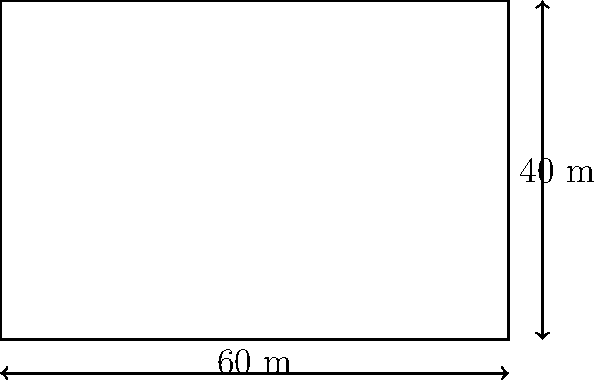Un client vous consulte concernant l'achat d'un terrain rectangulaire pour un projet immobilier. Le terrain mesure 60 mètres de long et 40 mètres de large. Quelle est la superficie totale du terrain en mètres carrés ? Pour calculer la superficie d'un terrain rectangulaire, nous utilisons la formule de l'aire d'un rectangle :

$$ A = l \times L $$

Où :
$A$ = l'aire (superficie)
$l$ = la largeur
$L$ = la longueur

Dans ce cas :
$l = 40$ mètres
$L = 60$ mètres

Appliquons la formule :

$$ A = 40 \times 60 = 2400 $$

Donc, la superficie totale du terrain est de 2400 mètres carrés.

Il est important de noter que dans le contexte juridique français, la superficie exacte d'un terrain est cruciale pour de nombreuses raisons, notamment :
1. La détermination du prix de vente
2. Le calcul des taxes foncières
3. La conformité avec les règlements d'urbanisme locaux
4. La planification des projets de construction
Answer: 2400 m² 